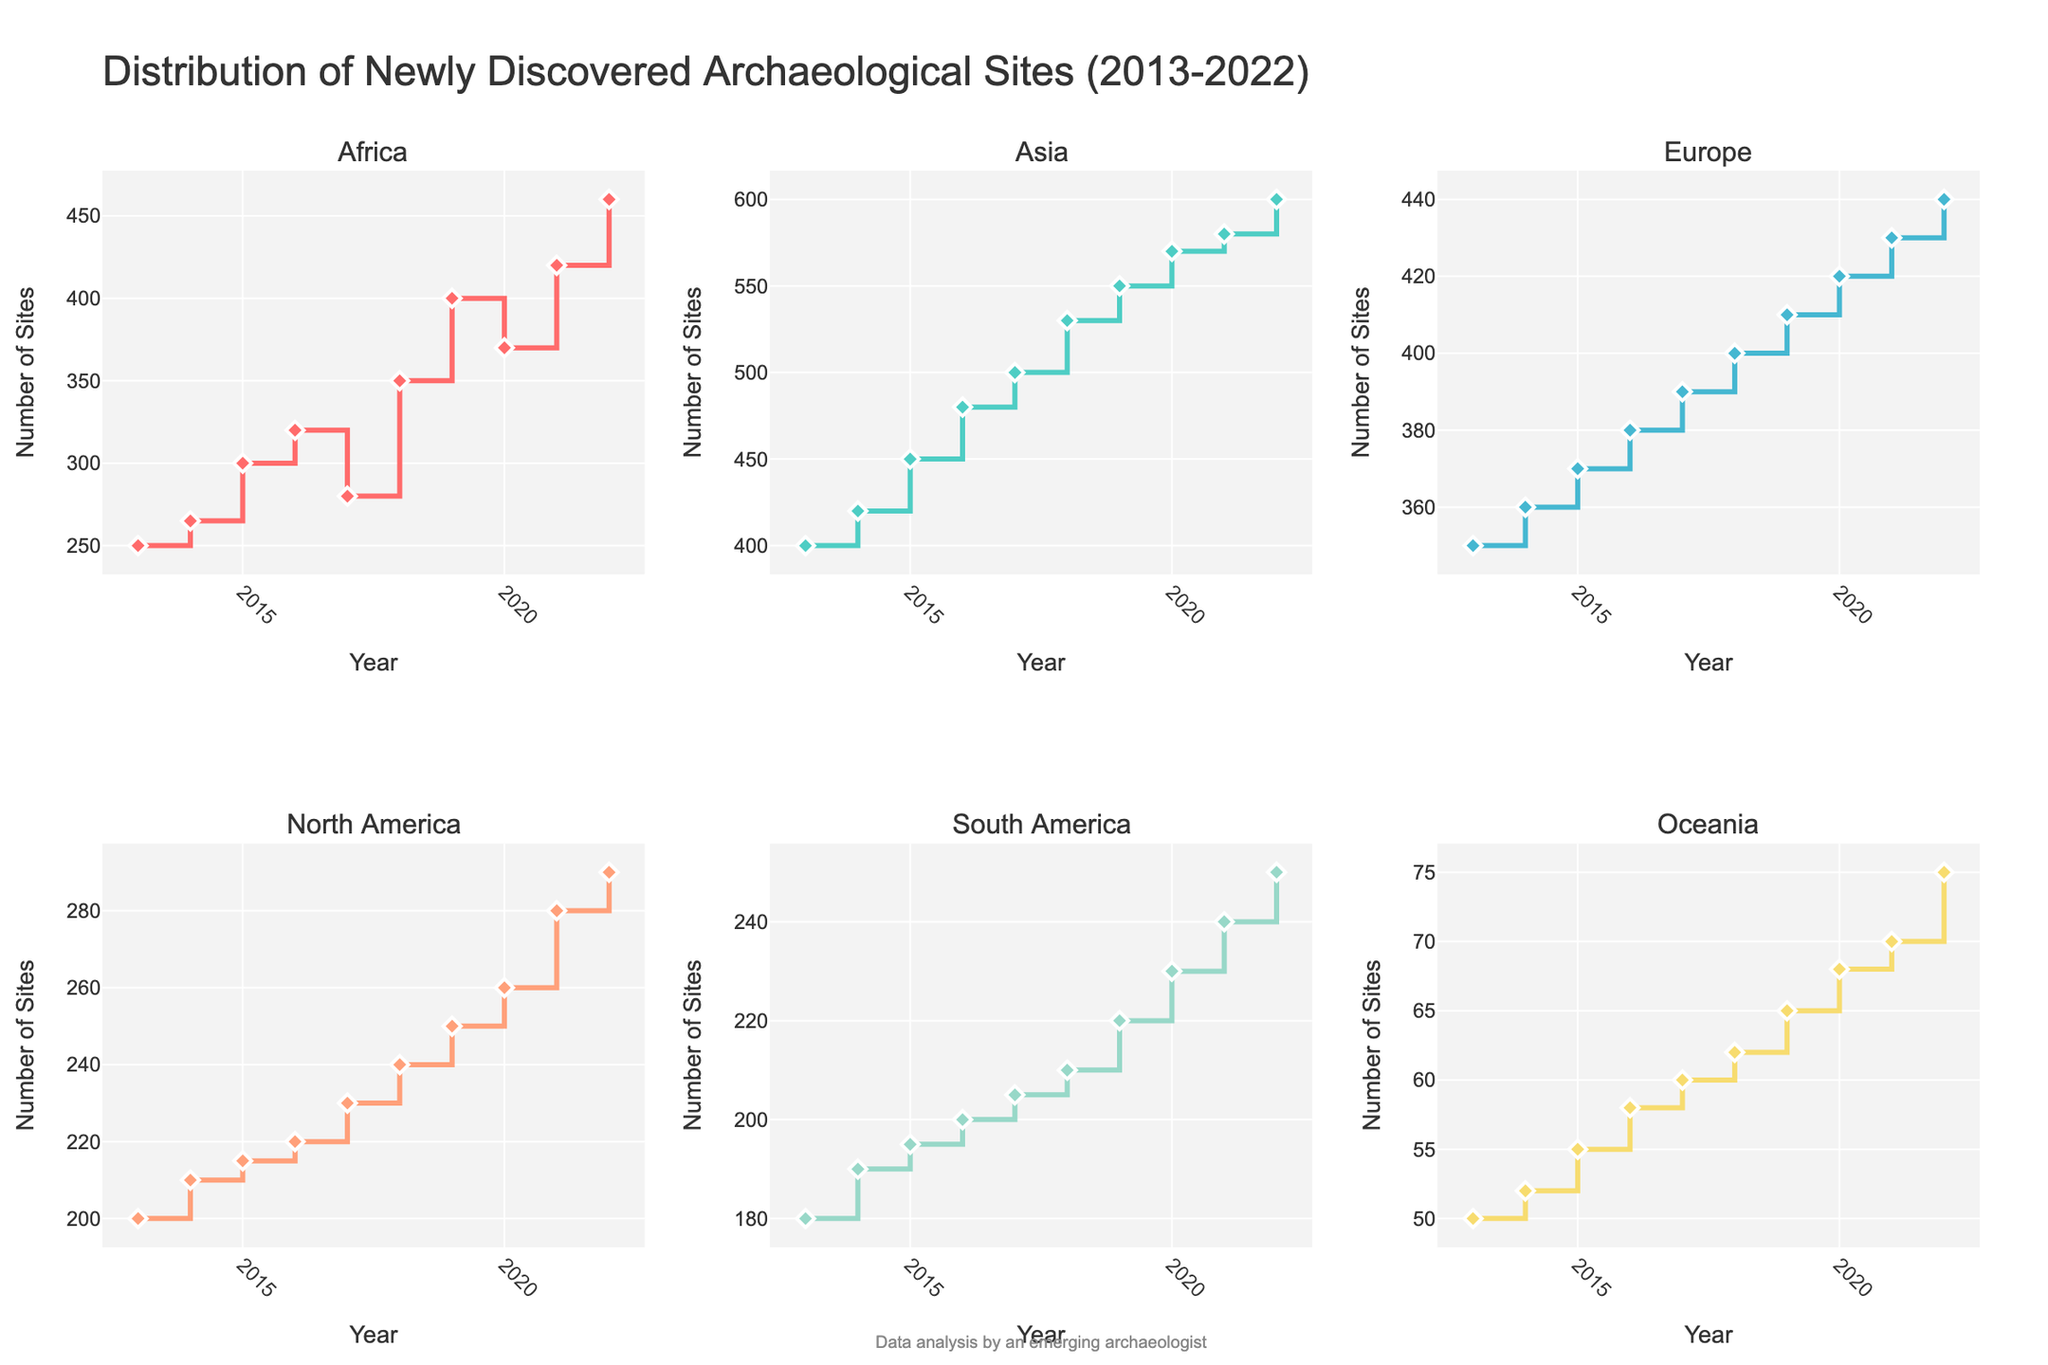What is the overall title of the figure? The title is prominently displayed at the top of the figure. It provides a general description of what the graph depicts.
Answer: Distribution of Newly Discovered Archaeological Sites (2013-2022) Which continent has the highest number of newly discovered archaeological sites in 2022? Check the y-axis value for all continents in the year 2022 and identify the one with the highest value.
Answer: Asia By how much did the number of newly discovered archaeological sites in Africa increase from 2013 to 2022? Locate the number of sites in Africa for 2013 and 2022, then calculate the difference: 460 (2022) - 250 (2013).
Answer: 210 How many continents saw their number of newly discovered archaeological sites increase every year from 2013 to 2022? Examine the trend lines for each continent and count the ones that consistently go up every year.
Answer: None Which got more newly discovered archaeological sites in 2015: North America or Oceania? Compare the y-values for North America and Oceania in 2015. North America has 215 and Oceania has 55.
Answer: North America What is the slope of the line during the steepest annual increase for South America? Identify the year in which the increase is the steepest for South America by looking for the largest gap between consecutive points. Calculate the rise over run for that specific interval, from 2013 (180) to 2014 (190): (190-180)/(2014-2013).
Answer: 10 Which continent shows a decline in the number of newly discovered sites in any year during the period? Examine the lines for any downward segments. Africa shows a decrease from 2017 to 2018.
Answer: Africa How did the number of newly discovered archaeological sites in Europe change from 2013 to 2022? Observe the general trend of the line for Europe from the start year to the end year. The number steadily increases.
Answer: Steadily increased How many newly discovered archaeological sites were there in South America in 2020? Check the y-axis value for South America for the year 2020.
Answer: 230 